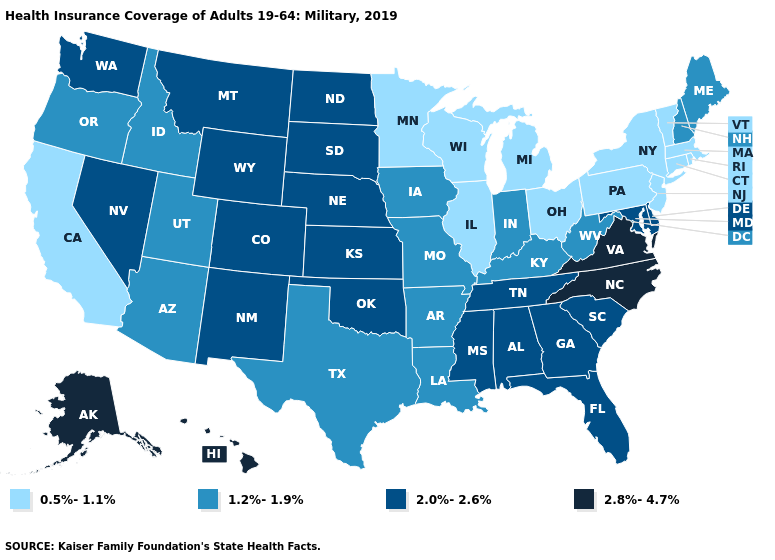What is the value of Utah?
Answer briefly. 1.2%-1.9%. Name the states that have a value in the range 2.0%-2.6%?
Be succinct. Alabama, Colorado, Delaware, Florida, Georgia, Kansas, Maryland, Mississippi, Montana, Nebraska, Nevada, New Mexico, North Dakota, Oklahoma, South Carolina, South Dakota, Tennessee, Washington, Wyoming. What is the lowest value in states that border Missouri?
Keep it brief. 0.5%-1.1%. Does Louisiana have the same value as New York?
Short answer required. No. Which states have the highest value in the USA?
Keep it brief. Alaska, Hawaii, North Carolina, Virginia. What is the highest value in the South ?
Concise answer only. 2.8%-4.7%. Name the states that have a value in the range 2.0%-2.6%?
Quick response, please. Alabama, Colorado, Delaware, Florida, Georgia, Kansas, Maryland, Mississippi, Montana, Nebraska, Nevada, New Mexico, North Dakota, Oklahoma, South Carolina, South Dakota, Tennessee, Washington, Wyoming. What is the highest value in the USA?
Keep it brief. 2.8%-4.7%. What is the value of Wyoming?
Quick response, please. 2.0%-2.6%. Which states have the highest value in the USA?
Give a very brief answer. Alaska, Hawaii, North Carolina, Virginia. Which states have the highest value in the USA?
Quick response, please. Alaska, Hawaii, North Carolina, Virginia. Among the states that border Utah , which have the highest value?
Give a very brief answer. Colorado, Nevada, New Mexico, Wyoming. Which states hav the highest value in the Northeast?
Quick response, please. Maine, New Hampshire. 